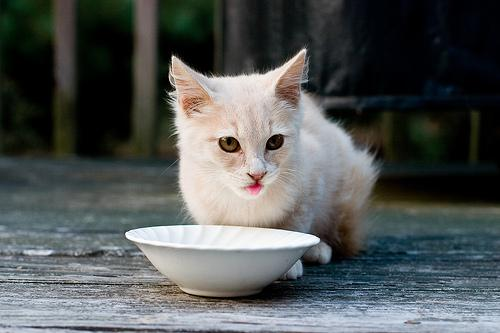Question: why is the cat sticking out his tongue?
Choices:
A. To lick it's nose.
B. To drink the milk.
C. To eat the snack.
D. Drinking his drink.
Answer with the letter. Answer: D Question: what is in front of the kitten?
Choices:
A. Bowl.
B. A plate.
C. A cup.
D. An apple.
Answer with the letter. Answer: A Question: when was the picture taken?
Choices:
A. At dawn.
B. At dusk.
C. Daytime.
D. Evening.
Answer with the letter. Answer: D 